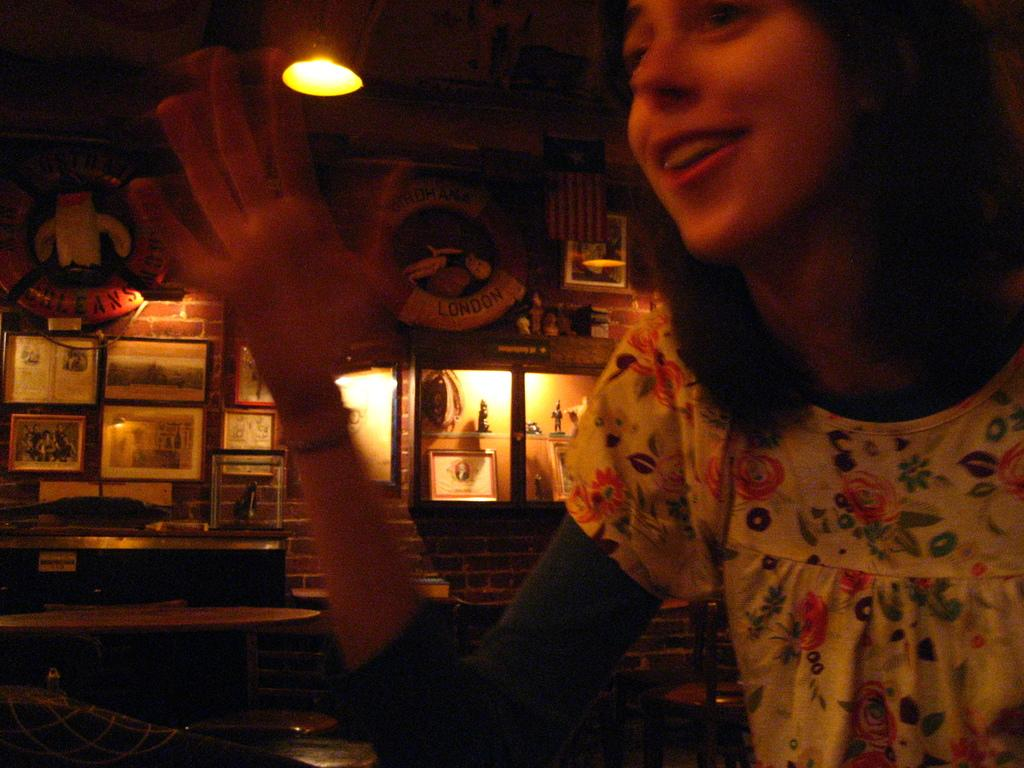Who or what is present in the image? There is a person in the image. What is the person wearing? The person is wearing a white shirt. What can be seen on the wall in the background? There are frames attached to the wall in the background. What source of illumination is visible in the image? There is a light visible in the image. What type of fowl can be seen sitting on the sofa in the image? There is no fowl or sofa present in the image. How many cans are visible on the person's shirt in the image? The person's shirt is white, and there are no cans visible on it. 